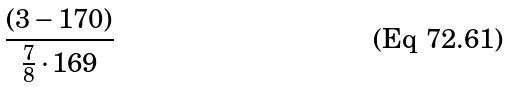<formula> <loc_0><loc_0><loc_500><loc_500>\frac { ( 3 - 1 7 0 ) } { \frac { 7 } { 8 } \cdot 1 6 9 }</formula> 